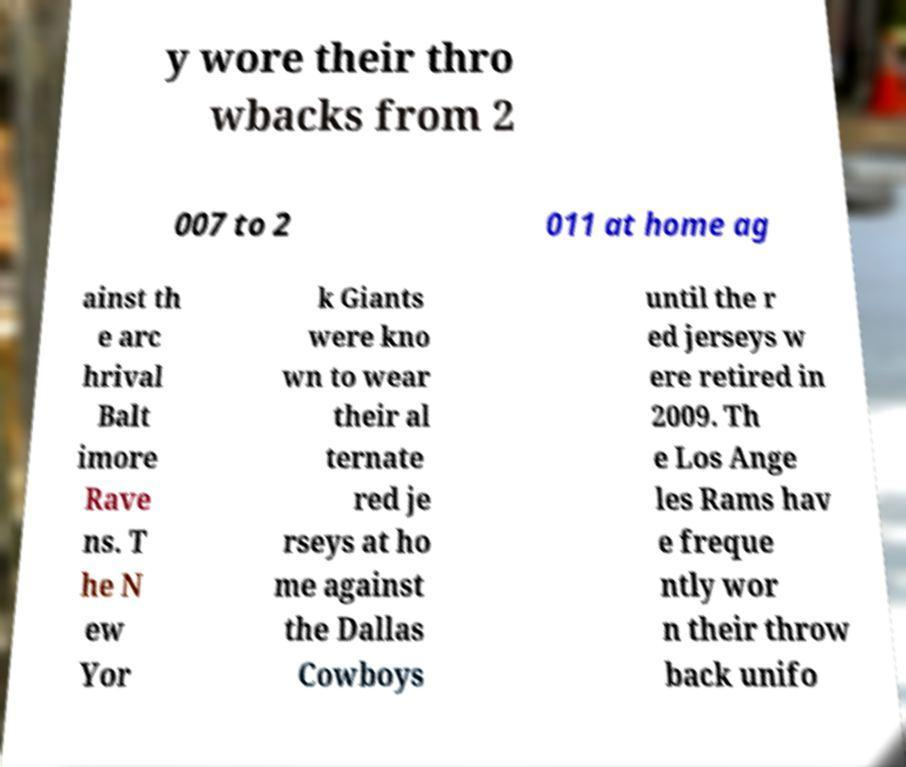There's text embedded in this image that I need extracted. Can you transcribe it verbatim? y wore their thro wbacks from 2 007 to 2 011 at home ag ainst th e arc hrival Balt imore Rave ns. T he N ew Yor k Giants were kno wn to wear their al ternate red je rseys at ho me against the Dallas Cowboys until the r ed jerseys w ere retired in 2009. Th e Los Ange les Rams hav e freque ntly wor n their throw back unifo 